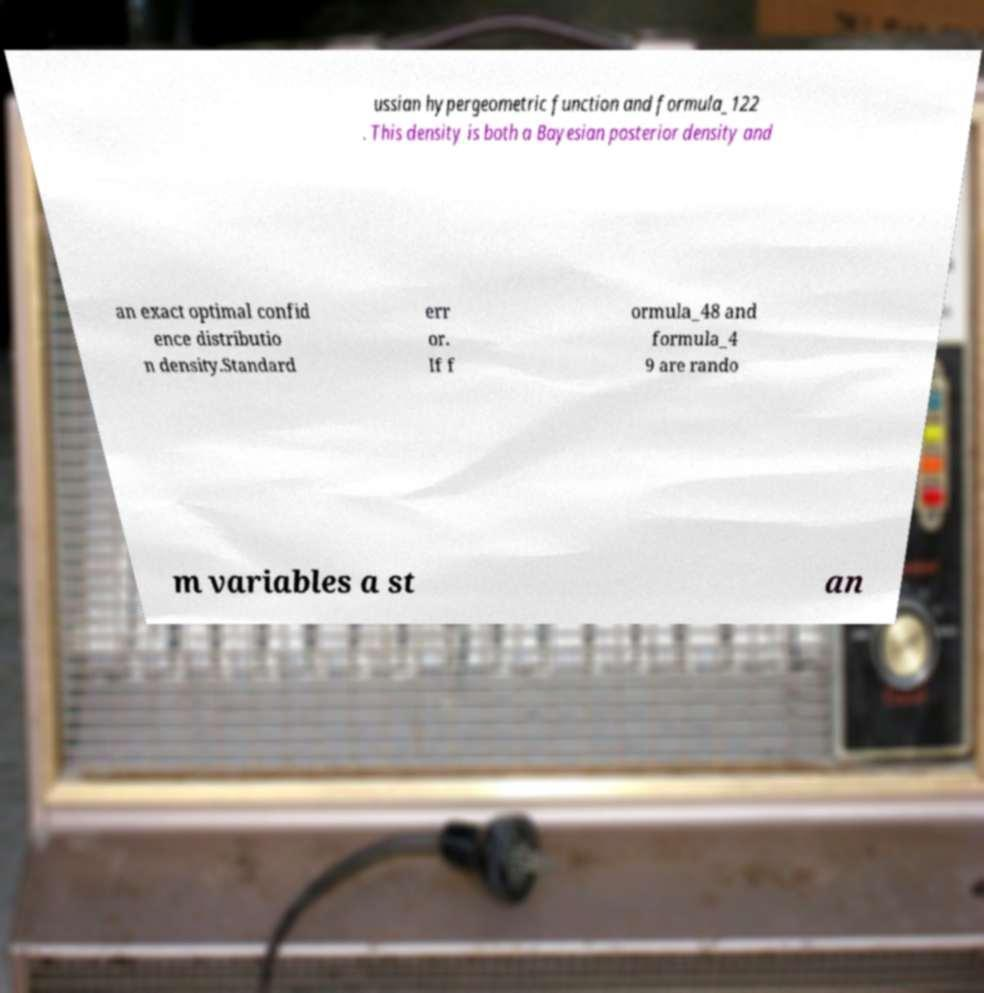Could you extract and type out the text from this image? ussian hypergeometric function and formula_122 . This density is both a Bayesian posterior density and an exact optimal confid ence distributio n density.Standard err or. If f ormula_48 and formula_4 9 are rando m variables a st an 